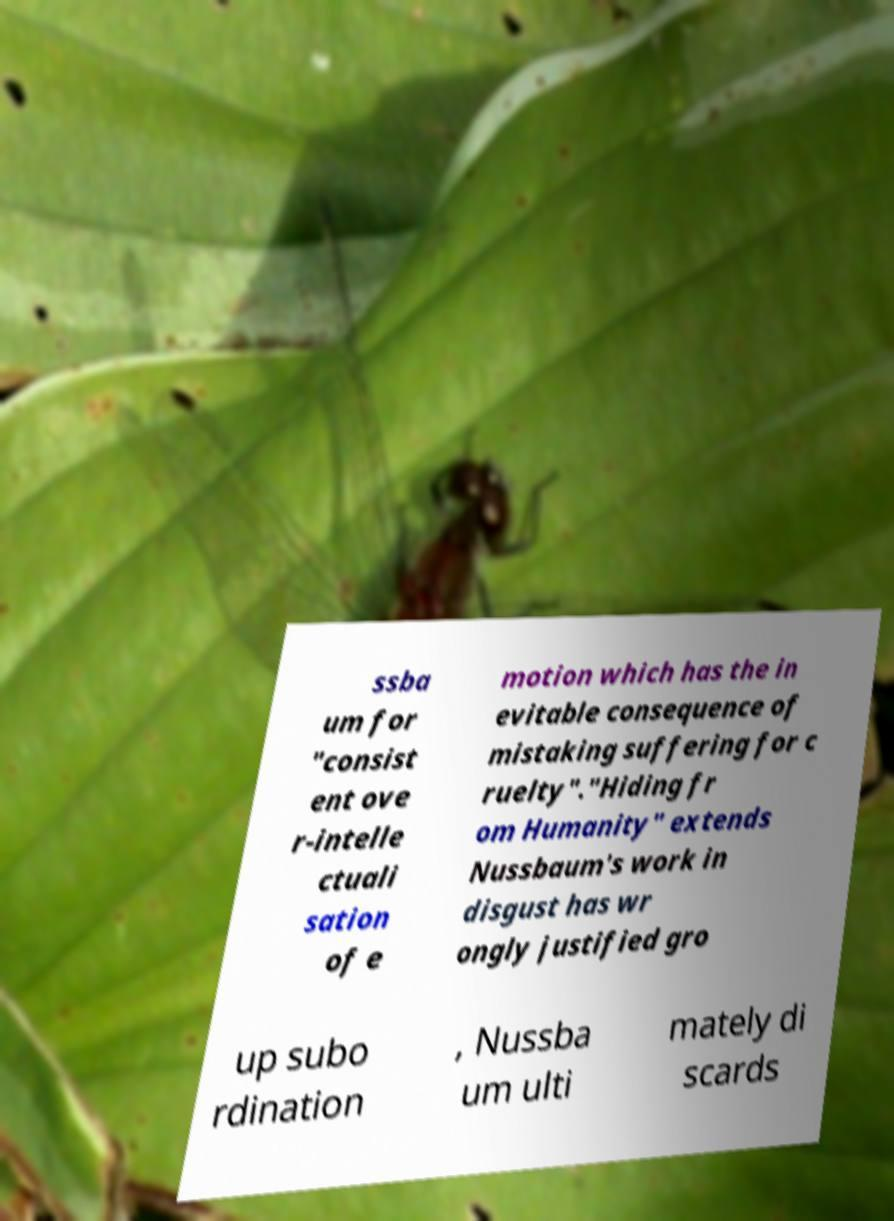Can you accurately transcribe the text from the provided image for me? ssba um for "consist ent ove r-intelle ctuali sation of e motion which has the in evitable consequence of mistaking suffering for c ruelty"."Hiding fr om Humanity" extends Nussbaum's work in disgust has wr ongly justified gro up subo rdination , Nussba um ulti mately di scards 